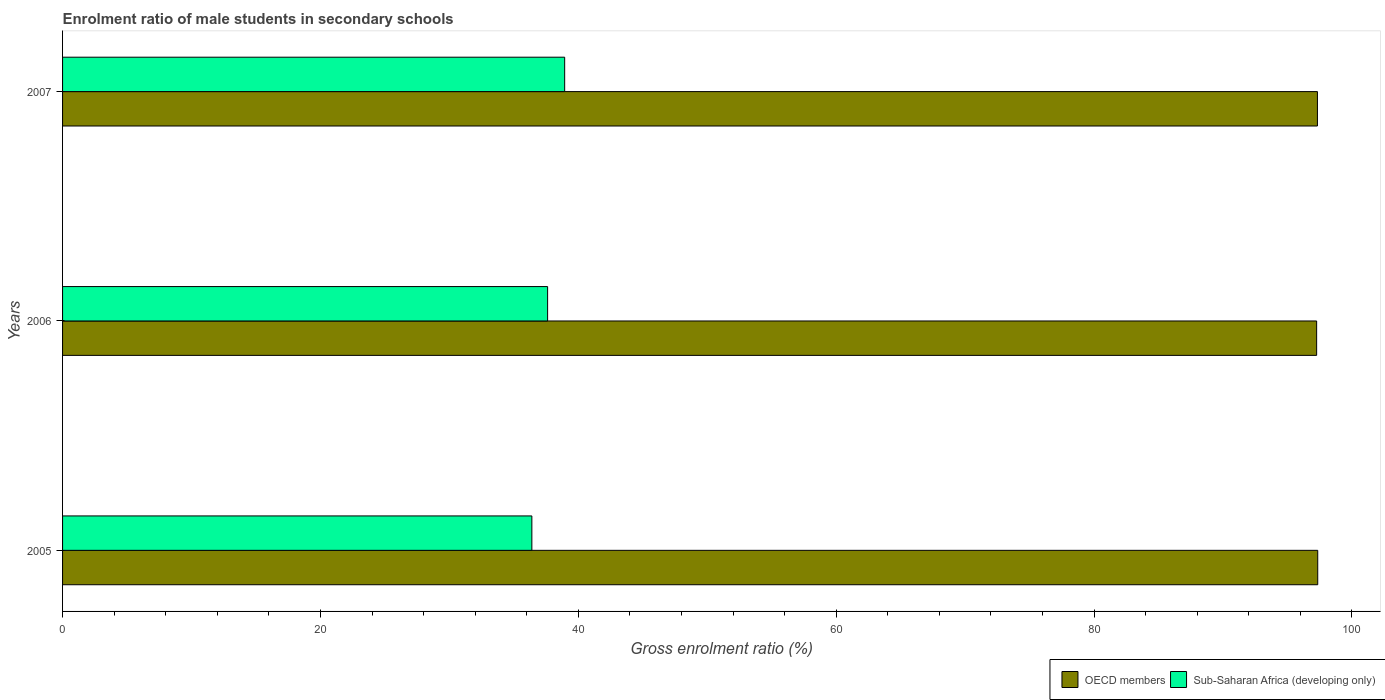How many different coloured bars are there?
Ensure brevity in your answer.  2. Are the number of bars per tick equal to the number of legend labels?
Offer a very short reply. Yes. How many bars are there on the 3rd tick from the top?
Keep it short and to the point. 2. How many bars are there on the 1st tick from the bottom?
Provide a short and direct response. 2. What is the label of the 2nd group of bars from the top?
Make the answer very short. 2006. What is the enrolment ratio of male students in secondary schools in Sub-Saharan Africa (developing only) in 2007?
Make the answer very short. 38.94. Across all years, what is the maximum enrolment ratio of male students in secondary schools in OECD members?
Provide a succinct answer. 97.35. Across all years, what is the minimum enrolment ratio of male students in secondary schools in Sub-Saharan Africa (developing only)?
Make the answer very short. 36.4. What is the total enrolment ratio of male students in secondary schools in OECD members in the graph?
Offer a terse response. 291.95. What is the difference between the enrolment ratio of male students in secondary schools in OECD members in 2005 and that in 2007?
Your response must be concise. 0.02. What is the difference between the enrolment ratio of male students in secondary schools in OECD members in 2006 and the enrolment ratio of male students in secondary schools in Sub-Saharan Africa (developing only) in 2007?
Give a very brief answer. 58.32. What is the average enrolment ratio of male students in secondary schools in Sub-Saharan Africa (developing only) per year?
Give a very brief answer. 37.65. In the year 2006, what is the difference between the enrolment ratio of male students in secondary schools in Sub-Saharan Africa (developing only) and enrolment ratio of male students in secondary schools in OECD members?
Your answer should be very brief. -59.65. In how many years, is the enrolment ratio of male students in secondary schools in OECD members greater than 20 %?
Provide a succinct answer. 3. What is the ratio of the enrolment ratio of male students in secondary schools in Sub-Saharan Africa (developing only) in 2005 to that in 2007?
Make the answer very short. 0.93. Is the enrolment ratio of male students in secondary schools in Sub-Saharan Africa (developing only) in 2005 less than that in 2007?
Keep it short and to the point. Yes. Is the difference between the enrolment ratio of male students in secondary schools in Sub-Saharan Africa (developing only) in 2005 and 2007 greater than the difference between the enrolment ratio of male students in secondary schools in OECD members in 2005 and 2007?
Offer a terse response. No. What is the difference between the highest and the second highest enrolment ratio of male students in secondary schools in OECD members?
Your answer should be very brief. 0.02. What is the difference between the highest and the lowest enrolment ratio of male students in secondary schools in Sub-Saharan Africa (developing only)?
Your answer should be compact. 2.55. What does the 2nd bar from the top in 2007 represents?
Your answer should be very brief. OECD members. What does the 2nd bar from the bottom in 2006 represents?
Offer a terse response. Sub-Saharan Africa (developing only). Are all the bars in the graph horizontal?
Your answer should be very brief. Yes. Are the values on the major ticks of X-axis written in scientific E-notation?
Your answer should be very brief. No. Does the graph contain any zero values?
Offer a terse response. No. Does the graph contain grids?
Provide a short and direct response. No. How many legend labels are there?
Provide a short and direct response. 2. How are the legend labels stacked?
Keep it short and to the point. Horizontal. What is the title of the graph?
Provide a short and direct response. Enrolment ratio of male students in secondary schools. What is the label or title of the Y-axis?
Your answer should be very brief. Years. What is the Gross enrolment ratio (%) of OECD members in 2005?
Your answer should be compact. 97.35. What is the Gross enrolment ratio (%) in Sub-Saharan Africa (developing only) in 2005?
Your answer should be very brief. 36.4. What is the Gross enrolment ratio (%) in OECD members in 2006?
Keep it short and to the point. 97.27. What is the Gross enrolment ratio (%) in Sub-Saharan Africa (developing only) in 2006?
Your response must be concise. 37.62. What is the Gross enrolment ratio (%) of OECD members in 2007?
Offer a terse response. 97.33. What is the Gross enrolment ratio (%) of Sub-Saharan Africa (developing only) in 2007?
Provide a short and direct response. 38.94. Across all years, what is the maximum Gross enrolment ratio (%) in OECD members?
Your answer should be very brief. 97.35. Across all years, what is the maximum Gross enrolment ratio (%) in Sub-Saharan Africa (developing only)?
Provide a succinct answer. 38.94. Across all years, what is the minimum Gross enrolment ratio (%) of OECD members?
Make the answer very short. 97.27. Across all years, what is the minimum Gross enrolment ratio (%) in Sub-Saharan Africa (developing only)?
Keep it short and to the point. 36.4. What is the total Gross enrolment ratio (%) of OECD members in the graph?
Provide a short and direct response. 291.95. What is the total Gross enrolment ratio (%) of Sub-Saharan Africa (developing only) in the graph?
Make the answer very short. 112.96. What is the difference between the Gross enrolment ratio (%) of OECD members in 2005 and that in 2006?
Offer a terse response. 0.09. What is the difference between the Gross enrolment ratio (%) of Sub-Saharan Africa (developing only) in 2005 and that in 2006?
Ensure brevity in your answer.  -1.22. What is the difference between the Gross enrolment ratio (%) in OECD members in 2005 and that in 2007?
Your answer should be very brief. 0.02. What is the difference between the Gross enrolment ratio (%) in Sub-Saharan Africa (developing only) in 2005 and that in 2007?
Offer a terse response. -2.55. What is the difference between the Gross enrolment ratio (%) in OECD members in 2006 and that in 2007?
Your answer should be very brief. -0.06. What is the difference between the Gross enrolment ratio (%) of Sub-Saharan Africa (developing only) in 2006 and that in 2007?
Provide a short and direct response. -1.32. What is the difference between the Gross enrolment ratio (%) in OECD members in 2005 and the Gross enrolment ratio (%) in Sub-Saharan Africa (developing only) in 2006?
Your response must be concise. 59.73. What is the difference between the Gross enrolment ratio (%) of OECD members in 2005 and the Gross enrolment ratio (%) of Sub-Saharan Africa (developing only) in 2007?
Offer a very short reply. 58.41. What is the difference between the Gross enrolment ratio (%) in OECD members in 2006 and the Gross enrolment ratio (%) in Sub-Saharan Africa (developing only) in 2007?
Provide a succinct answer. 58.32. What is the average Gross enrolment ratio (%) of OECD members per year?
Keep it short and to the point. 97.32. What is the average Gross enrolment ratio (%) of Sub-Saharan Africa (developing only) per year?
Provide a succinct answer. 37.65. In the year 2005, what is the difference between the Gross enrolment ratio (%) of OECD members and Gross enrolment ratio (%) of Sub-Saharan Africa (developing only)?
Your answer should be very brief. 60.95. In the year 2006, what is the difference between the Gross enrolment ratio (%) of OECD members and Gross enrolment ratio (%) of Sub-Saharan Africa (developing only)?
Give a very brief answer. 59.65. In the year 2007, what is the difference between the Gross enrolment ratio (%) of OECD members and Gross enrolment ratio (%) of Sub-Saharan Africa (developing only)?
Your response must be concise. 58.38. What is the ratio of the Gross enrolment ratio (%) in Sub-Saharan Africa (developing only) in 2005 to that in 2006?
Provide a short and direct response. 0.97. What is the ratio of the Gross enrolment ratio (%) in OECD members in 2005 to that in 2007?
Keep it short and to the point. 1. What is the ratio of the Gross enrolment ratio (%) of Sub-Saharan Africa (developing only) in 2005 to that in 2007?
Provide a succinct answer. 0.93. What is the ratio of the Gross enrolment ratio (%) in OECD members in 2006 to that in 2007?
Your response must be concise. 1. What is the difference between the highest and the second highest Gross enrolment ratio (%) in OECD members?
Ensure brevity in your answer.  0.02. What is the difference between the highest and the second highest Gross enrolment ratio (%) of Sub-Saharan Africa (developing only)?
Keep it short and to the point. 1.32. What is the difference between the highest and the lowest Gross enrolment ratio (%) in OECD members?
Your answer should be compact. 0.09. What is the difference between the highest and the lowest Gross enrolment ratio (%) of Sub-Saharan Africa (developing only)?
Make the answer very short. 2.55. 